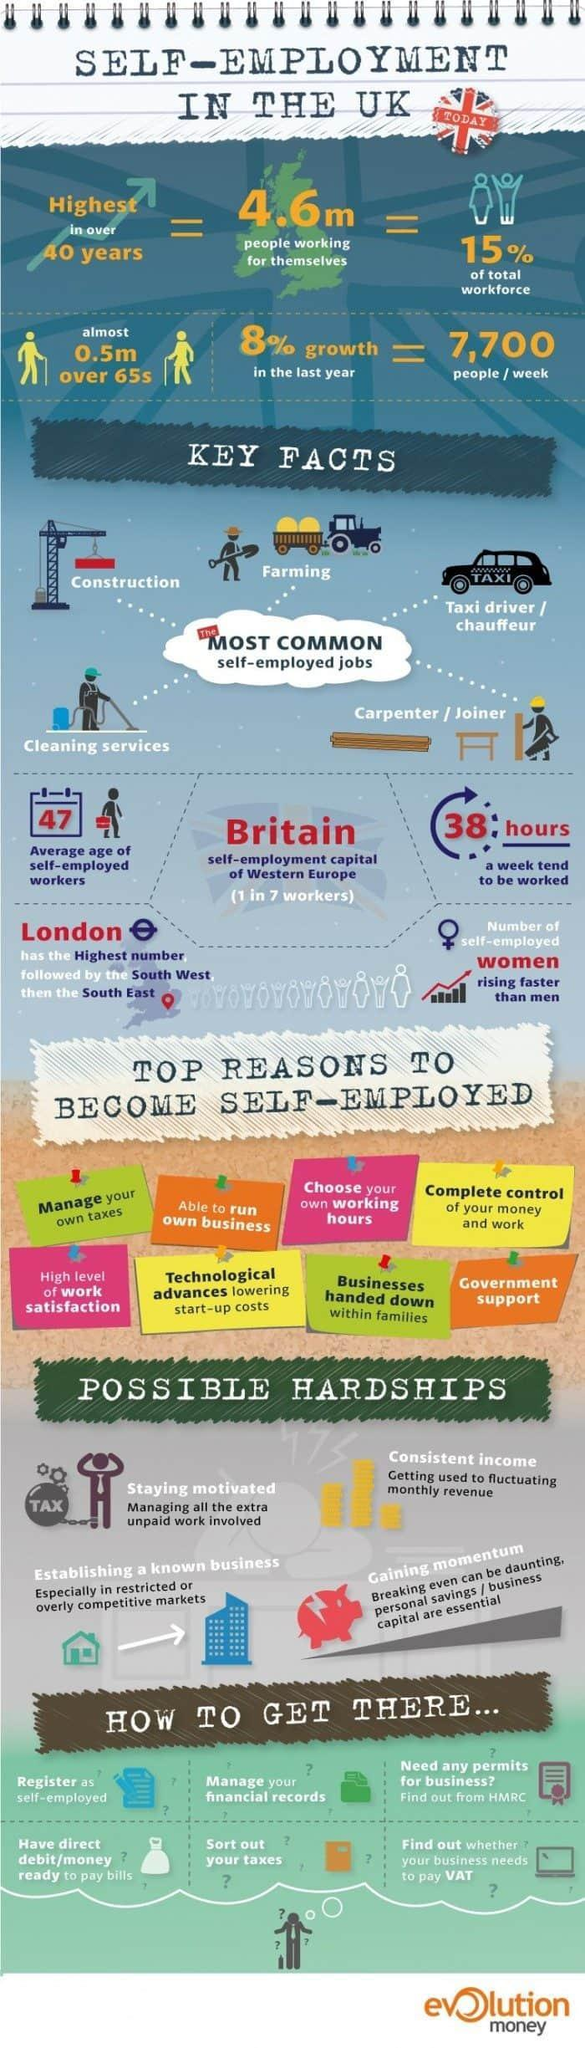Which part of the UK is ranked as having the third most number of self employed workers South East, South West, or London?
Answer the question with a short phrase. South East How many common types of self employed jobs are listed? 5 Which part of the UK has the second highest number of Self employed people in the UK? South West 